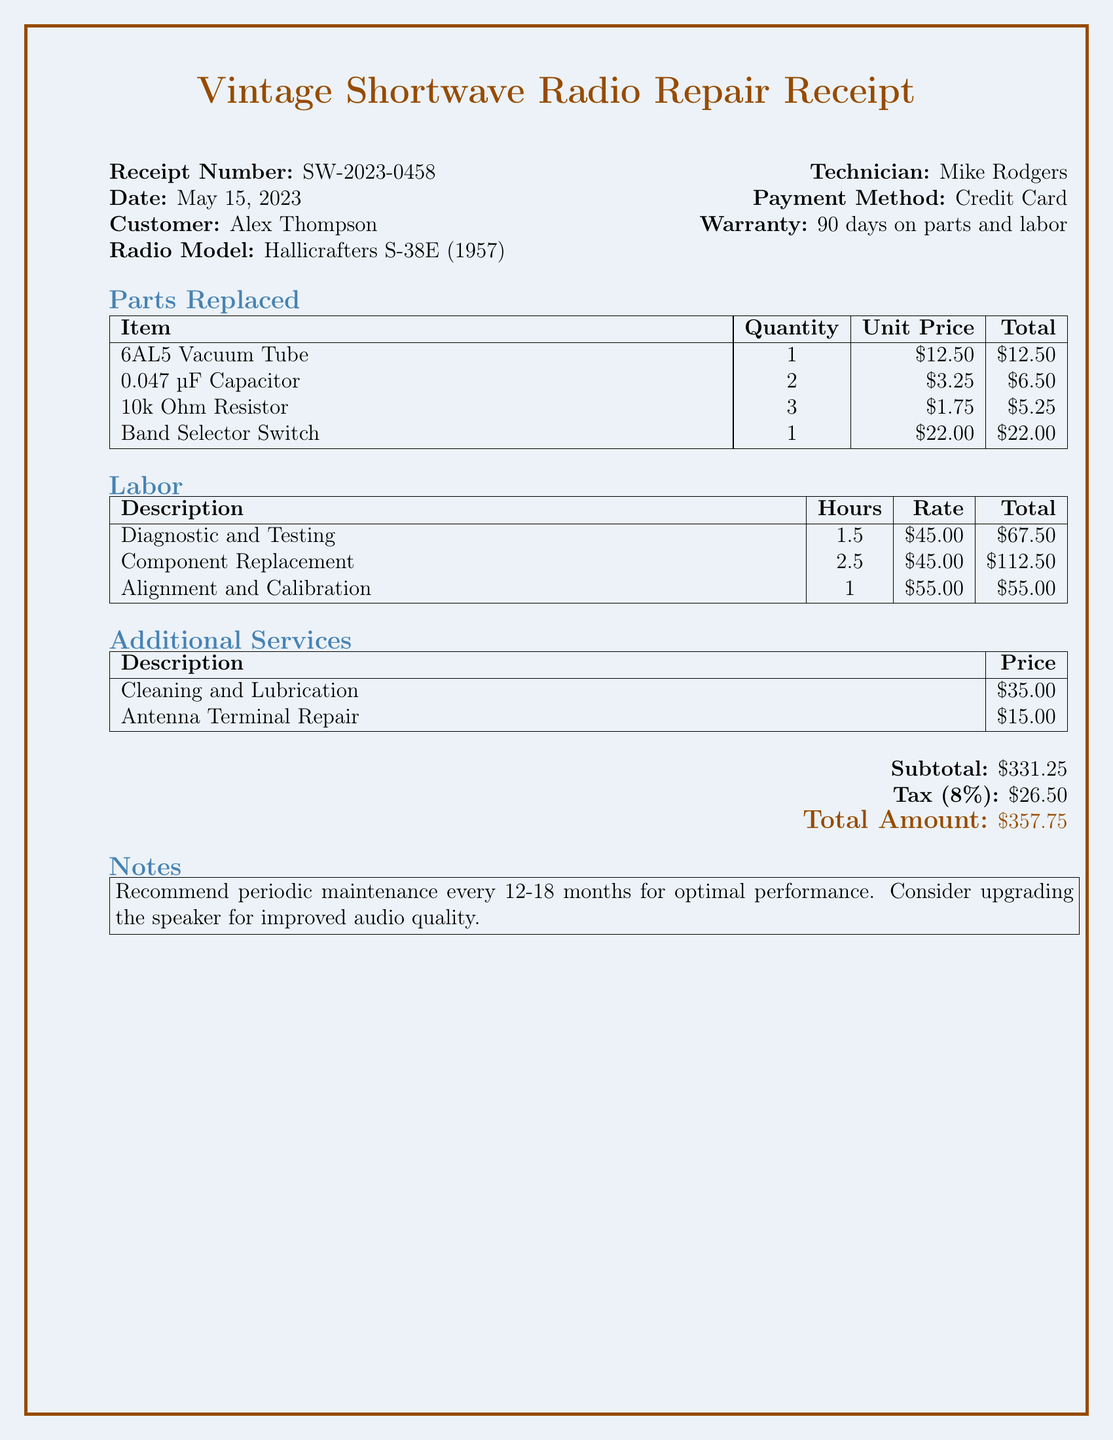What is the receipt number? The receipt number is provided at the top of the document, which helps uniquely identify this transaction.
Answer: SW-2023-0458 Who was the technician? The technician's name is mentioned, indicating who performed the repair work on the radio.
Answer: Mike Rodgers What is the total amount charged? The total amount is calculated by adding the subtotal and tax, which is provided at the bottom of the document.
Answer: $357.75 How many 0.047 µF capacitors were replaced? The document lists the quantities of parts replaced, indicating how many of each part were fixed.
Answer: 2 What is the tax rate applied? The tax rate is specified directly in the document, indicating the percentage added to the subtotal for tax calculation.
Answer: 8% What labor task took the most hours? The labor tasks along with their corresponding hours show which work required the most time.
Answer: Component Replacement What warranty is provided? The warranty information is stated clearly in the document, informing about the coverage duration.
Answer: 90 days on parts and labor What suggestion is made regarding maintenance? The document contains notes recommending actions to maintain the radio and improve its performance based on best practices.
Answer: Recommend periodic maintenance every 12-18 months What payment method was used? The payment method for the transaction is explicitly mentioned in the document.
Answer: Credit Card 